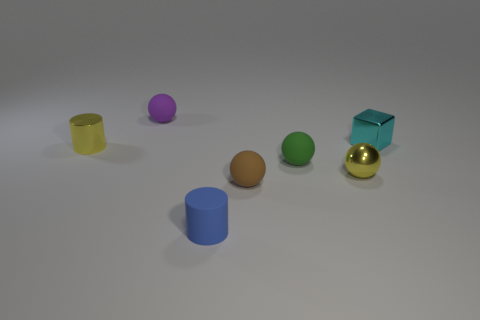Is there anything else that is made of the same material as the tiny block?
Your answer should be compact. Yes. Do the tiny brown rubber object and the object that is behind the small cyan block have the same shape?
Your answer should be compact. Yes. How many other objects are there of the same size as the green ball?
Provide a succinct answer. 6. Are there more large brown shiny cylinders than tiny metal cylinders?
Your answer should be very brief. No. What number of things are both on the left side of the purple rubber thing and to the right of the tiny brown matte thing?
Your answer should be compact. 0. The tiny metal thing behind the thing on the left side of the small matte ball that is behind the cyan metallic cube is what shape?
Your answer should be very brief. Cube. Is there anything else that has the same shape as the purple thing?
Make the answer very short. Yes. What number of cylinders are small matte objects or cyan metallic objects?
Your response must be concise. 1. Does the tiny metal thing in front of the yellow cylinder have the same color as the tiny shiny cylinder?
Your response must be concise. Yes. There is a yellow object that is to the right of the matte sphere that is in front of the tiny metal ball in front of the green matte object; what is its material?
Your answer should be compact. Metal. 